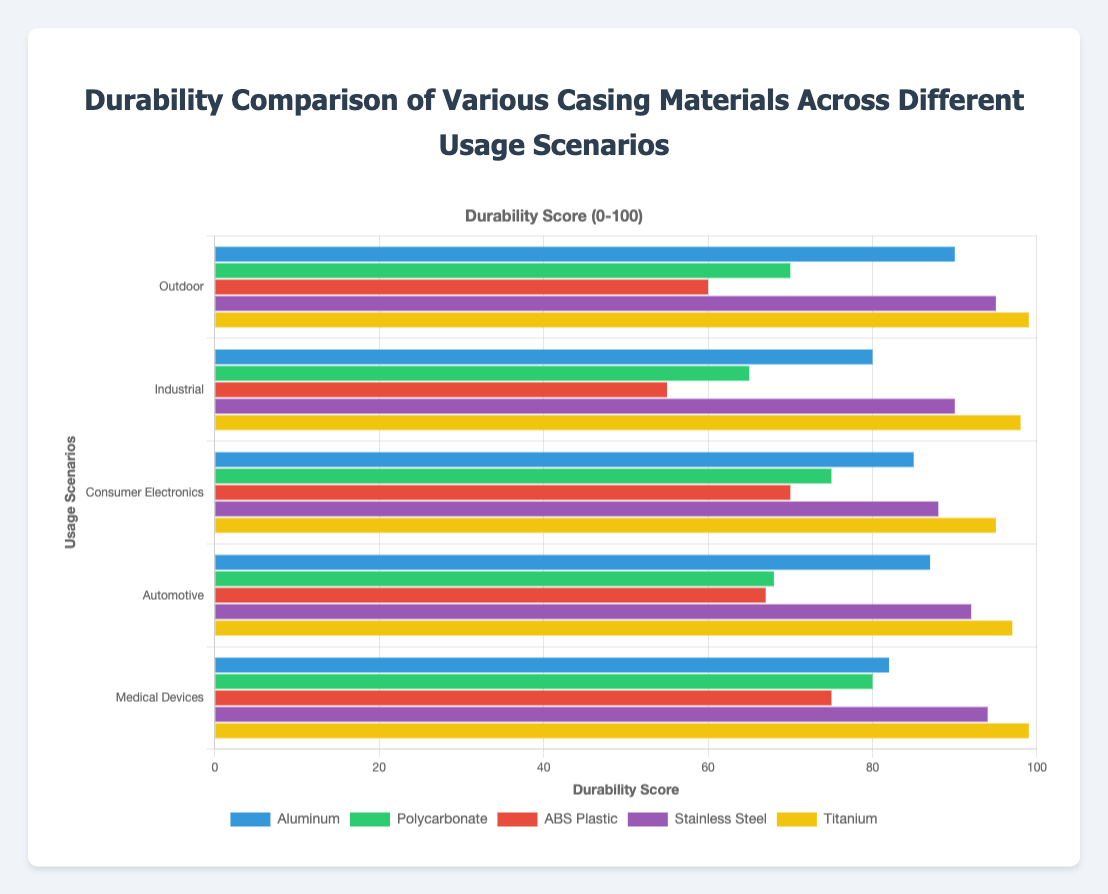What's the most durable material for medical devices? The figure shows the durability scores for various materials in different usage scenarios. Looking at the Medical Devices category, Titanium has the highest score.
Answer: Titanium Which material performs the worst in Industrial scenarios? By looking at the Industrial category, ABS Plastic has the lowest durability score among all the materials listed.
Answer: ABS Plastic What's the average durability score of Polycarbonate across all usage scenarios? The Polycarbonate scores are 70 (Outdoor), 65 (Industrial), 75 (Consumer Electronics), 68 (Automotive), and 80 (Medical Devices). Adding these scores together gives 70 + 65 + 75 + 68 + 80 = 358. The average is 358 / 5 = 71.6.
Answer: 71.6 Which material shows the most consistent durability across all usage scenarios? Consistency can be measured by the range (difference between highest and lowest scores). Aluminum: 90-80=10, Polycarbonate: 80-65=15, ABS Plastic: 75-55=20, Stainless Steel: 95-88=7, Titanium: 99-95=4. Titanium has the smallest range (4), indicating the most consistent performance.
Answer: Titanium Is Stainless Steel more durable for Consumer Electronics or Automotive usage scenarios? The durability score for Stainless Steel in the Consumer Electronics category is 88, while in the Automotive category, it’s 92. Therefore, it is more durable in Automotive usage scenarios.
Answer: Automotive What's the difference in durability between the best and worst-performing materials in Outdoor usage? In the Outdoor category, Titanium has the highest score (99), and ABS Plastic has the lowest score (60). The difference is 99 - 60 = 39.
Answer: 39 List the materials in descending order of durability for Automotive usage. For the Automotive usage scenario, the durability scores are: Titanium - 97, Stainless Steel - 92, Aluminum - 87, ABS Plastic - 67, Polycarbonate - 68. The descending order is: Titanium, Stainless Steel, Aluminum, Polycarbonate, ABS Plastic.
Answer: Titanium, Stainless Steel, Aluminum, Polycarbonate, ABS Plastic How does Titanium's durability in Consumer Electronics compare to its durability in Medical Devices? The score for Titanium in Consumer Electronics is 95, and in Medical Devices, it is 99. Titanium is slightly more durable in Medical Devices.
Answer: Medical Devices What's the median durability score of ABS Plastic across all scenarios? The scores for ABS Plastic are: 60 (Outdoor), 55 (Industrial), 70 (Consumer Electronics), 67 (Automotive), 75 (Medical Devices). Arranged in order: 55, 60, 67, 70, 75. The median is the middle value, which is 67.
Answer: 67 